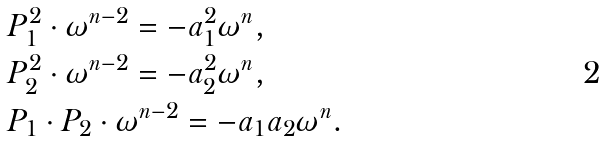<formula> <loc_0><loc_0><loc_500><loc_500>& P _ { 1 } ^ { 2 } \cdot \omega ^ { n - 2 } = - a _ { 1 } ^ { 2 } \omega ^ { n } , \\ & P _ { 2 } ^ { 2 } \cdot \omega ^ { n - 2 } = - a _ { 2 } ^ { 2 } \omega ^ { n } , \\ & P _ { 1 } \cdot P _ { 2 } \cdot \omega ^ { n - 2 } = - a _ { 1 } a _ { 2 } \omega ^ { n } .</formula> 